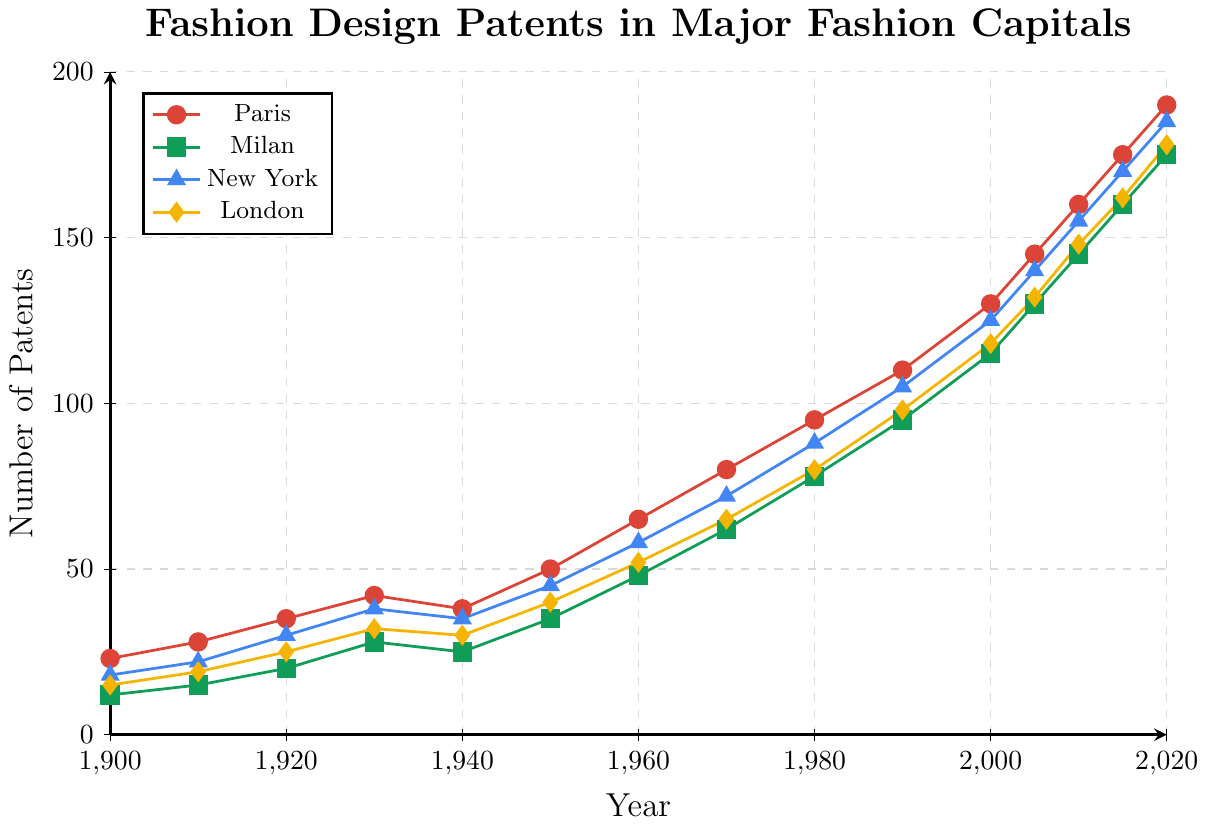What's the overall trend in the number of fashion design patents filed in Paris from 1900 to 2020? Over time, the number of fashion design patents filed in Paris generally increased. The count rose from 23 in 1900 to 190 in 2020. This indicates a consistent upward trend over the years.
Answer: Increasing Which city had the highest number of patents filed in 2020? By examining the endpoints of each line, Paris had the highest number of patents filed in 2020 with a count of 190, as compared to Milan (175), New York (185), and London (178).
Answer: Paris How do the patents filed in Milan in 1920 compare to those in New York in 1920? In 1920, the number of patents filed in Milan was 20, while in New York, it was 30. Thus, New York had more patents filed than Milan in 1920.
Answer: New York had more What was the combined number of patents filed in Paris and London in 1950? Looking at the values for Paris (50) and London (40) in 1950, their combined total is 50 + 40 = 90.
Answer: 90 From which decade did New York start having more patents filed than London? Comparing the data decade by decade, New York surpassed London in the number of patents filed starting in the 1960s. New York had 58 patents, while London had 52 patents in 1960.
Answer: 1960s Which city saw the sharpest increase in patents filed from 1970 to 1980? By comparing the increase in patent numbers between 1970 and 1980 for all cities: Paris increased from 80 to 95 (+15), Milan from 62 to 78 (+16), New York from 72 to 88 (+16), London from 65 to 80 (+15). Milan and New York had the same sharpest increase of +16 patents.
Answer: Milan and New York What is the average number of patents filed by all cities in 1940? Adding the patents filed in 1940 for all cities gives 38 (Paris) + 25 (Milan) + 35 (New York) + 30 (London) = 128. Dividing by 4 cities, the average number of patents filed is 128 / 4 = 32.
Answer: 32 Which city had the smallest increase in patents filed between 2000 and 2005? Comparing the increases for each city between 2000 and 2005: Paris increased from 130 to 145 (+15), Milan from 115 to 130 (+15), New York from 125 to 140 (+15), and London from 118 to 132 (+14). London had the smallest increase (+14).
Answer: London How many more patents were filed in Paris than in Milan in 2010? The number of patents filed in 2010 was 160 in Paris and 145 in Milan. Hence, Paris filed 160 - 145 = 15 more patents than Milan.
Answer: 15 